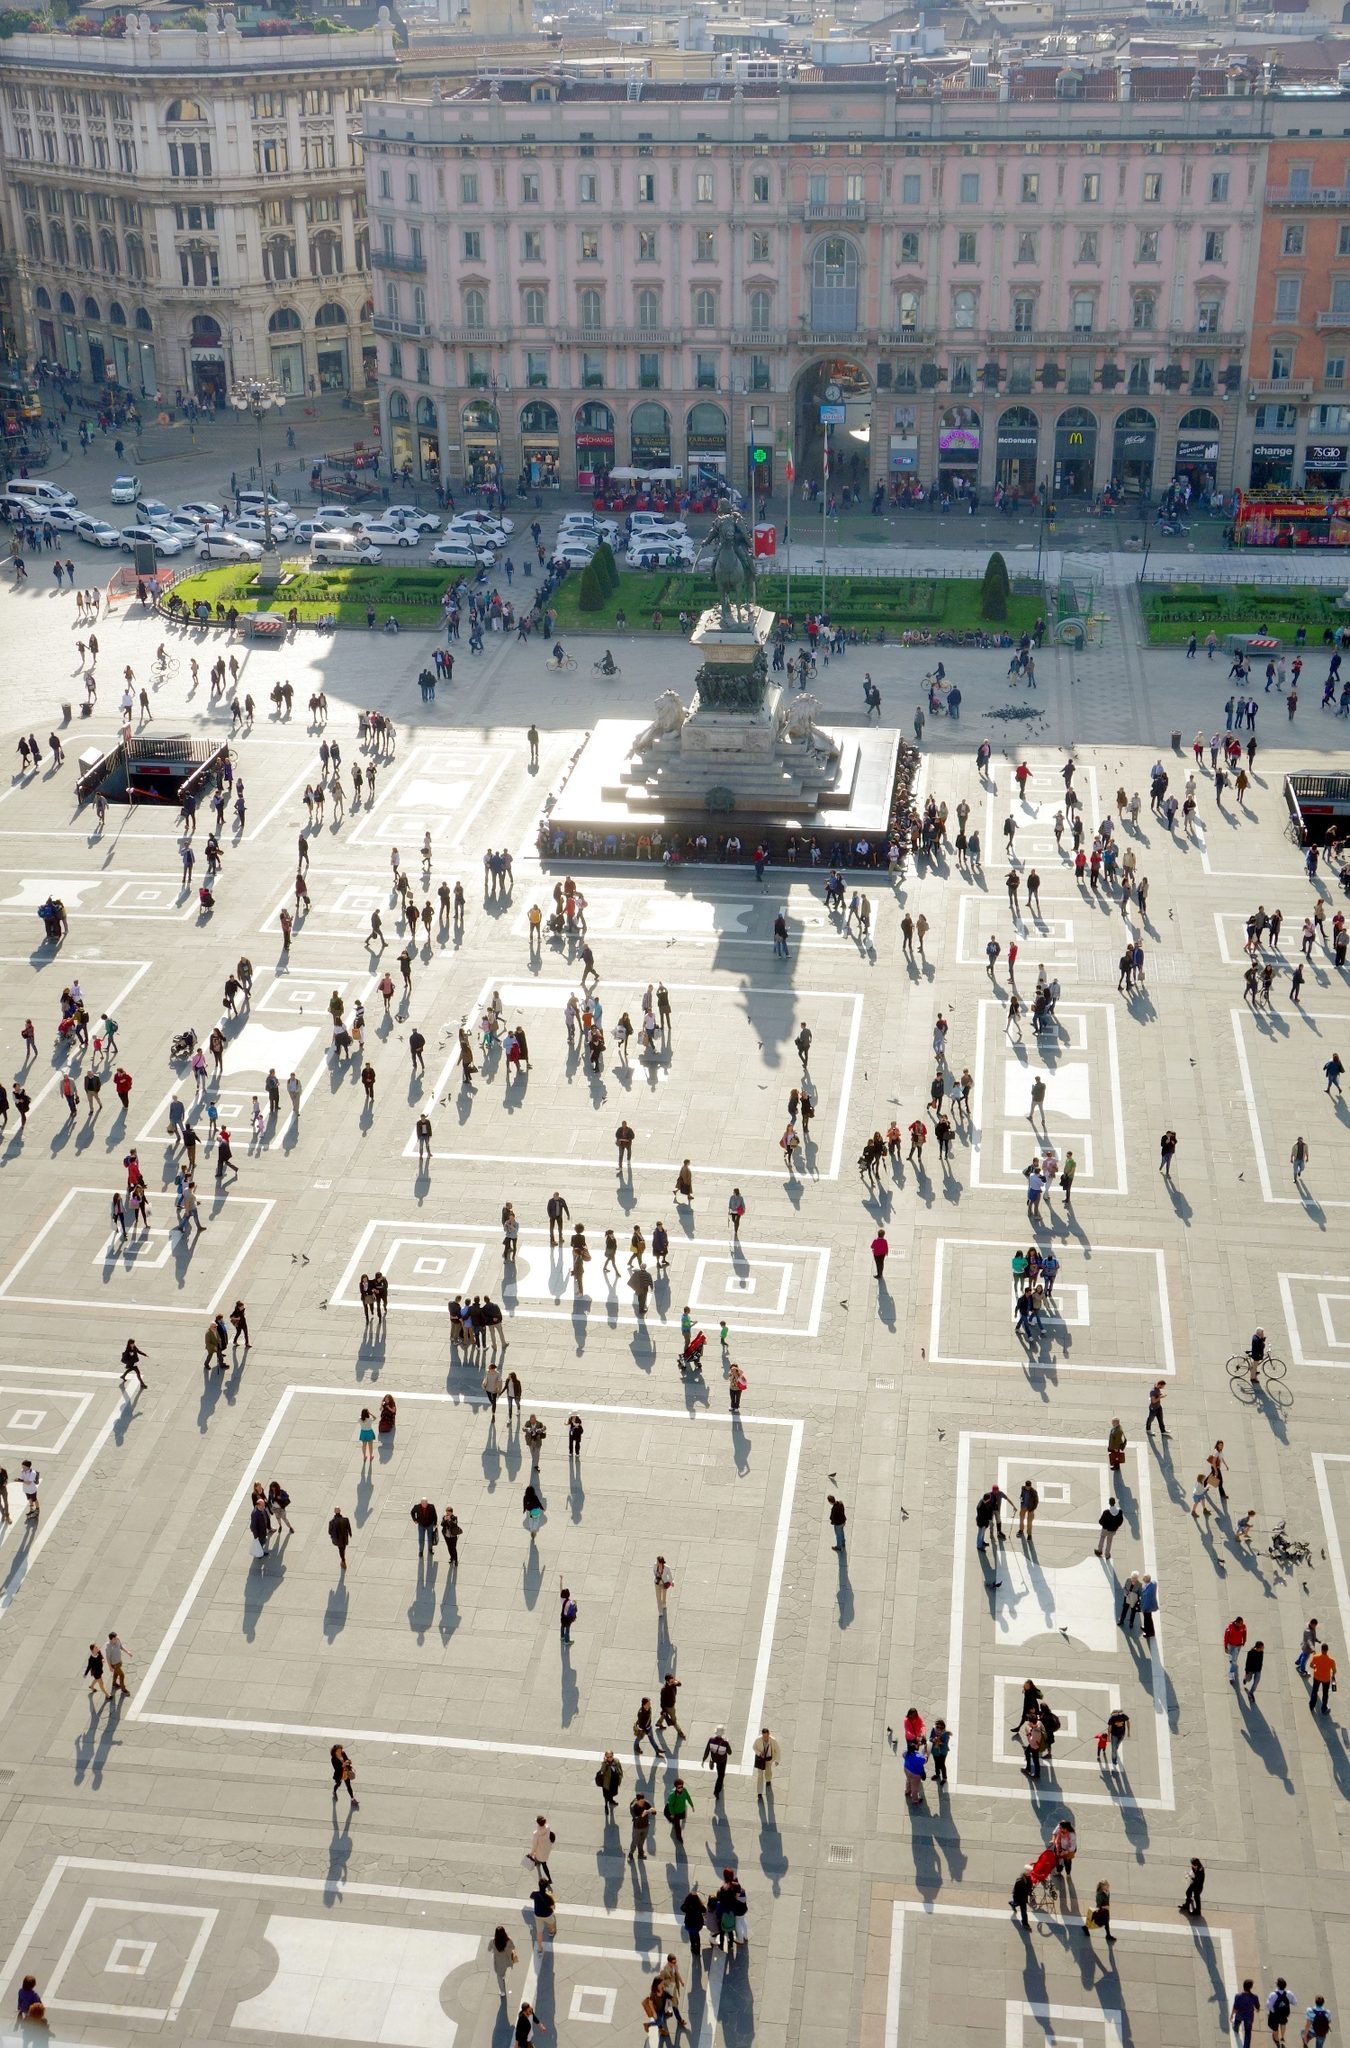Could you describe a short fictional story that takes place in this piazza? In the heart of Milan, on a sun-drenched afternoon, young Luca gazed up at the towering Cathedral in the Piazza del Duomo. His grandfather had told him tales of an ancient legend, where a hidden treasure lay beneath the statue of Vittorio Emanuele II. Luca, with his friends, decided today was the day they would uncover this mystery. Armed with an old map and unwavering determination, they set off on an adventure through the bustling square, weaving through the crowd. What did they find beneath the statue? Beneath the statue, they discovered a concealed entrance leading to an underground chamber. Inside, Luca and his friends found a trove of historical artifacts – ancient coins, ornate jewelry, and scrolls detailing Milan’s rich past. Among these treasures was a small, ornate box inscribed with a message from the past. As they opened it, they found a precious relic presumed lost to time: a beautifully crafted golden medallion said to hold the power of Milano’s prosperity. This discovery cemented their place in the annals of history, unveiling secrets that had been buried for centuries. 